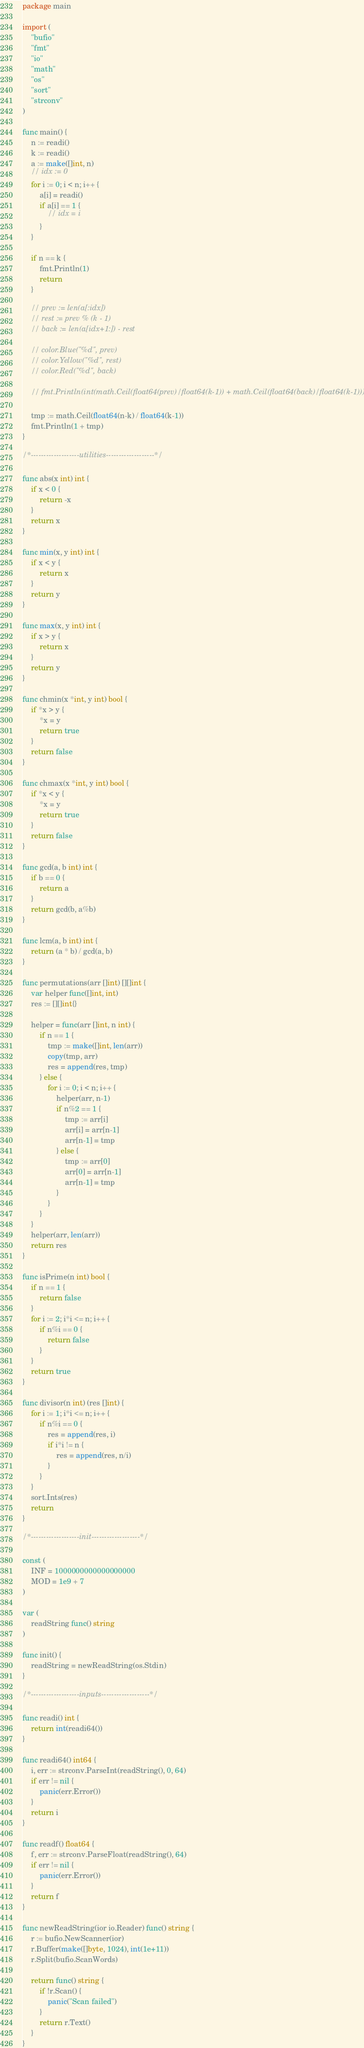<code> <loc_0><loc_0><loc_500><loc_500><_Go_>package main

import (
	"bufio"
	"fmt"
	"io"
	"math"
	"os"
	"sort"
	"strconv"
)

func main() {
	n := readi()
	k := readi()
	a := make([]int, n)
	// idx := 0
	for i := 0; i < n; i++ {
		a[i] = readi()
		if a[i] == 1 {
			// idx = i
		}
	}

	if n == k {
		fmt.Println(1)
		return
	}

	// prev := len(a[:idx])
	// rest := prev % (k - 1)
	// back := len(a[idx+1:]) - rest

	// color.Blue("%d", prev)
	// color.Yellow("%d", rest)
	// color.Red("%d", back)

	// fmt.Println(int(math.Ceil(float64(prev)/float64(k-1)) + math.Ceil(float64(back)/float64(k-1))))

	tmp := math.Ceil(float64(n-k) / float64(k-1))
	fmt.Println(1 + tmp)
}

/*-------------------utilities-------------------*/

func abs(x int) int {
	if x < 0 {
		return -x
	}
	return x
}

func min(x, y int) int {
	if x < y {
		return x
	}
	return y
}

func max(x, y int) int {
	if x > y {
		return x
	}
	return y
}

func chmin(x *int, y int) bool {
	if *x > y {
		*x = y
		return true
	}
	return false
}

func chmax(x *int, y int) bool {
	if *x < y {
		*x = y
		return true
	}
	return false
}

func gcd(a, b int) int {
	if b == 0 {
		return a
	}
	return gcd(b, a%b)
}

func lcm(a, b int) int {
	return (a * b) / gcd(a, b)
}

func permutations(arr []int) [][]int {
	var helper func([]int, int)
	res := [][]int{}

	helper = func(arr []int, n int) {
		if n == 1 {
			tmp := make([]int, len(arr))
			copy(tmp, arr)
			res = append(res, tmp)
		} else {
			for i := 0; i < n; i++ {
				helper(arr, n-1)
				if n%2 == 1 {
					tmp := arr[i]
					arr[i] = arr[n-1]
					arr[n-1] = tmp
				} else {
					tmp := arr[0]
					arr[0] = arr[n-1]
					arr[n-1] = tmp
				}
			}
		}
	}
	helper(arr, len(arr))
	return res
}

func isPrime(n int) bool {
	if n == 1 {
		return false
	}
	for i := 2; i*i <= n; i++ {
		if n%i == 0 {
			return false
		}
	}
	return true
}

func divisor(n int) (res []int) {
	for i := 1; i*i <= n; i++ {
		if n%i == 0 {
			res = append(res, i)
			if i*i != n {
				res = append(res, n/i)
			}
		}
	}
	sort.Ints(res)
	return
}

/*-------------------init-------------------*/

const (
	INF = 1000000000000000000
	MOD = 1e9 + 7
)

var (
	readString func() string
)

func init() {
	readString = newReadString(os.Stdin)
}

/*-------------------inputs-------------------*/

func readi() int {
	return int(readi64())
}

func readi64() int64 {
	i, err := strconv.ParseInt(readString(), 0, 64)
	if err != nil {
		panic(err.Error())
	}
	return i
}

func readf() float64 {
	f, err := strconv.ParseFloat(readString(), 64)
	if err != nil {
		panic(err.Error())
	}
	return f
}

func newReadString(ior io.Reader) func() string {
	r := bufio.NewScanner(ior)
	r.Buffer(make([]byte, 1024), int(1e+11))
	r.Split(bufio.ScanWords)

	return func() string {
		if !r.Scan() {
			panic("Scan failed")
		}
		return r.Text()
	}
}
</code> 